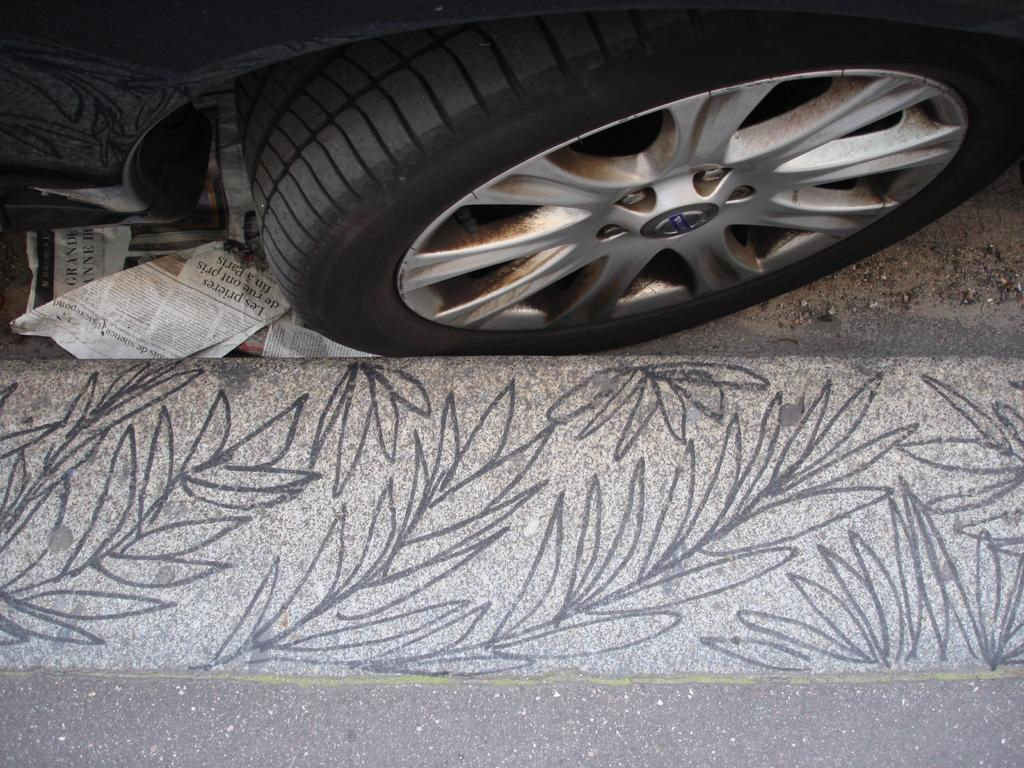What object is the main focus of the image? There is a vehicle wheel in the image. What type of religious ceremony is taking place in the hall in the image? There is no hall or religious ceremony present in the image; it only features a vehicle wheel. 